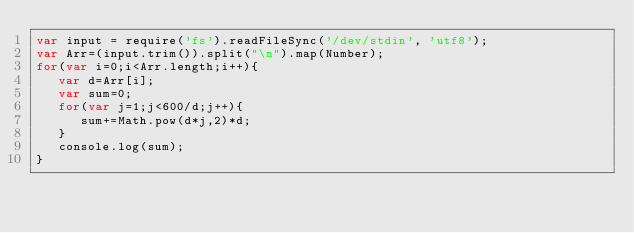<code> <loc_0><loc_0><loc_500><loc_500><_JavaScript_>var input = require('fs').readFileSync('/dev/stdin', 'utf8');
var Arr=(input.trim()).split("\n").map(Number);
for(var i=0;i<Arr.length;i++){
   var d=Arr[i];
   var sum=0;
   for(var j=1;j<600/d;j++){
      sum+=Math.pow(d*j,2)*d;
   }
   console.log(sum);
}</code> 